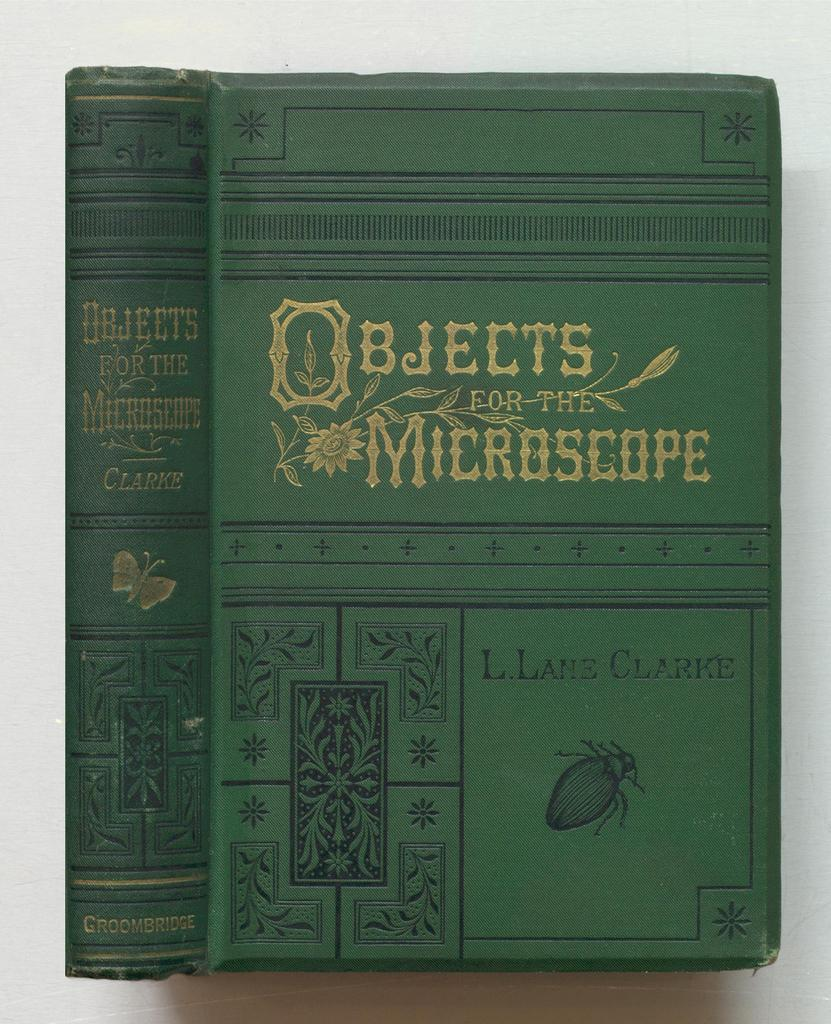Provide a one-sentence caption for the provided image. An old looking booked called Objects for the Microscope. 